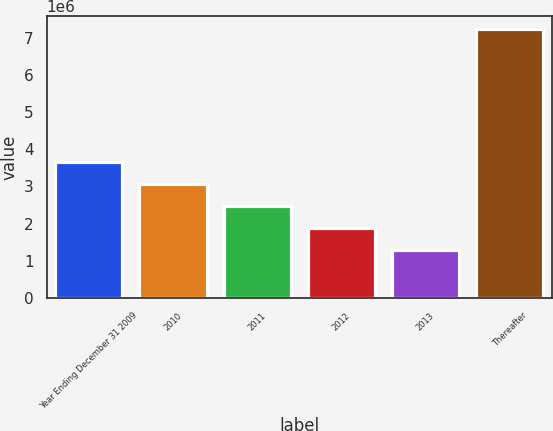Convert chart to OTSL. <chart><loc_0><loc_0><loc_500><loc_500><bar_chart><fcel>Year Ending December 31 2009<fcel>2010<fcel>2011<fcel>2012<fcel>2013<fcel>Thereafter<nl><fcel>3.6664e+06<fcel>3.0748e+06<fcel>2.4832e+06<fcel>1.8916e+06<fcel>1.3e+06<fcel>7.216e+06<nl></chart> 